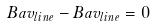Convert formula to latex. <formula><loc_0><loc_0><loc_500><loc_500>B a v _ { l i n e } - B a v _ { l i n e } = 0</formula> 